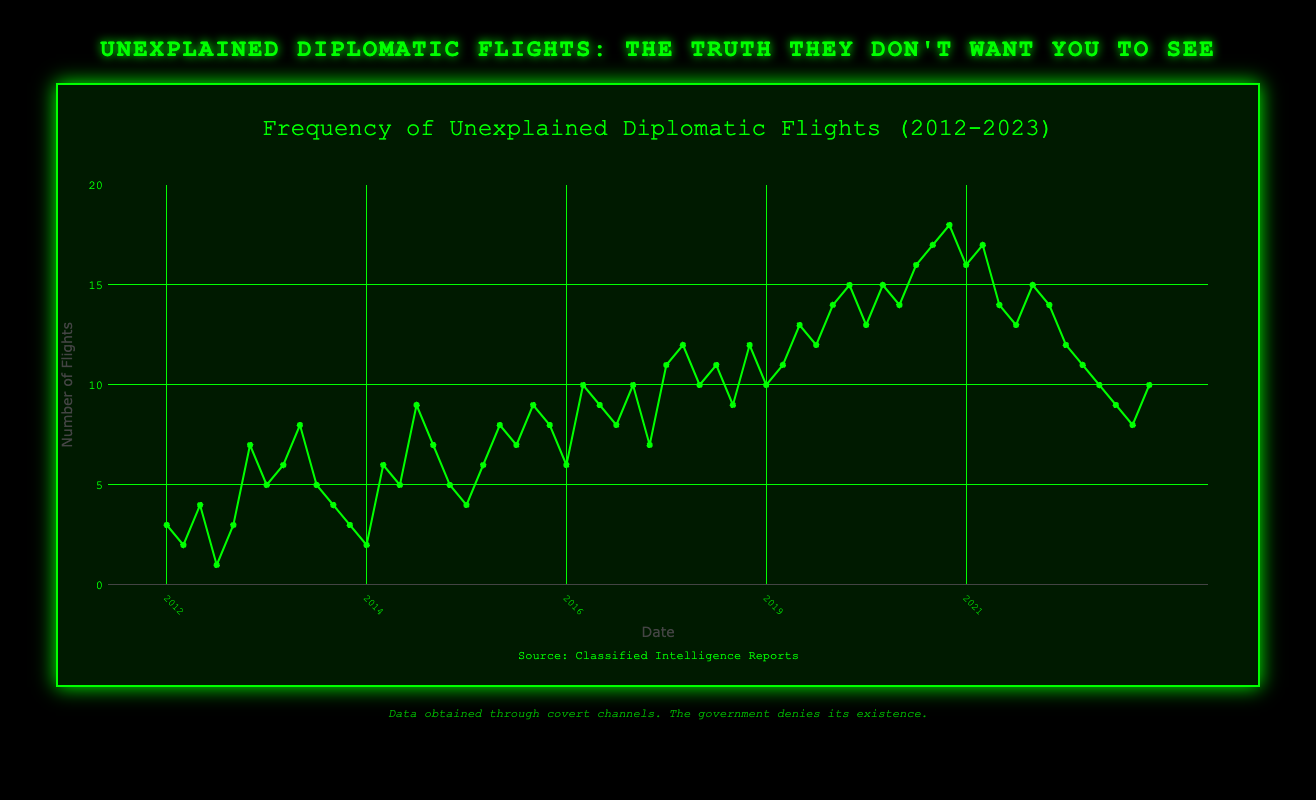What is the maximum number of unexplained diplomatic flights recorded in a single month? Observe the highest point on the plot's y-axis, which corresponds to the month of March 2021 with 18 flights.
Answer: 18 In which year did unexplained diplomatic flights first exceed 10 flights in a month? Identify the first year where the plot reaches above 10 flights on the y-axis. The first occurrence is in January 2017 with 10 flights.
Answer: 2017 Compare the total number of flights in January 2021 and January 2022. Which year saw more flights and by how many? January 2021 recorded 16 flights, whereas January 2022 recorded 14 flights. Subtracting these values gives 16 - 14 = 2 more flights in January 2021.
Answer: January 2021, by 2 How does the frequency of unexplained diplomatic flights in April 2020 compare to that in April 2013? April 2020 recorded 15 flights, while April 2013 had 8 flights. Subtracting these values gives 15 - 8 = 7 more flights in April 2020.
Answer: 7 more in 2020 What is the average number of unexplained diplomatic flights per month for the year 2015? The flights for 2015 are January: 9, February: 7, March: 5, April: 4, May: 6, totaling 9 + 7 + 5 + 4 + 6 = 31. The average is 31 / 5 = 6.2 flights per month.
Answer: 6.2 During which month and year did the number of unexplained diplomatic flights return to a count of 10 after the peak in March 2021? After March 2021 with 18 flights, the count returns to 10 in May 2023.
Answer: May 2023 Was there a consistent trend of increasing flights every year from 2012 to 2021? Observe the trend on the plot from 2012 to 2021. There is no consistent yearly increase; some years see decreases, for example, from 2013 to 2014.
Answer: No How many months in total recorded 12 or more unexplained diplomatic flights from 2012 to 2023? Count the number of months with flights ≥ 12 by inspecting the plot for each year: 11 months in total (2018-Feb, 2019-Jan, 2019-Mar, 2019-Apr, 2019-May, 2020-Jan, 2020-Feb, 2020-Apr, 2020-May, 2021-Jan, 2021-Feb).
Answer: 11 Which year experienced the greatest increase in unexplained diplomatic flights from January to March? Calculate the increase for each year by subtracting January values from March values: the maximum increase is 2 for 2021 (18 - 16 = 2).
Answer: 2021 Identify the month with the fewest unexplained diplomatic flights and state the number of flights. The month of April 2012 recorded the fewest flights with only 1 recorded.
Answer: April 2012, 1 